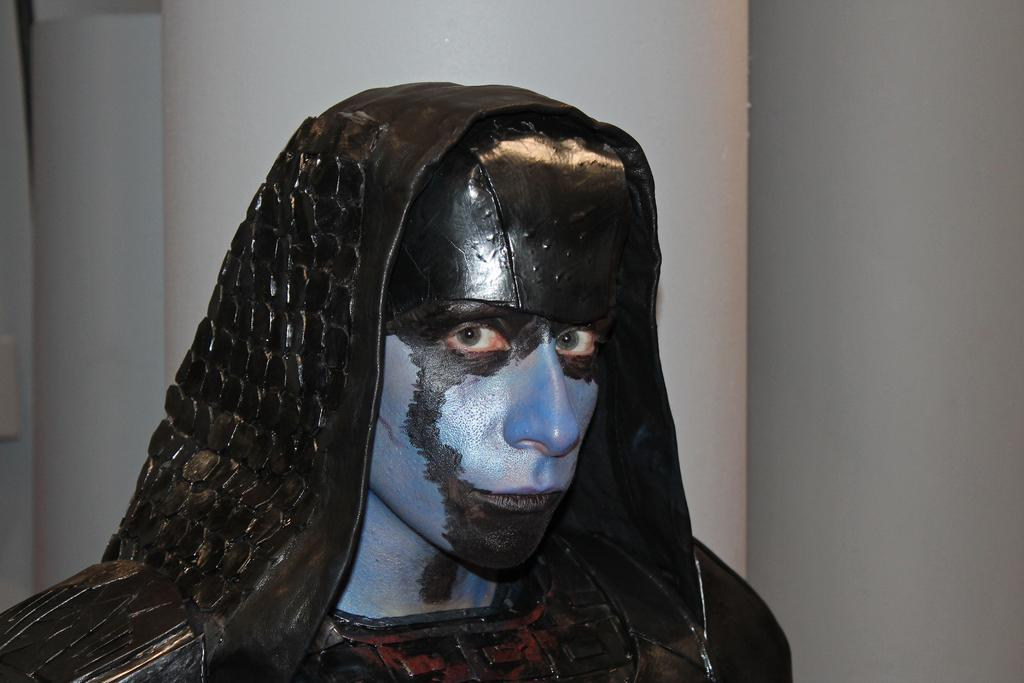Who is the main subject in the image? There is a man in the image. Where is the man located in the image? The man is in the center of the image. What can be seen in the background of the image? There is a white wall in the background of the image. What is the temperature in the image? The provided facts do not mention the temperature or heat in the image, so it cannot be determined. 